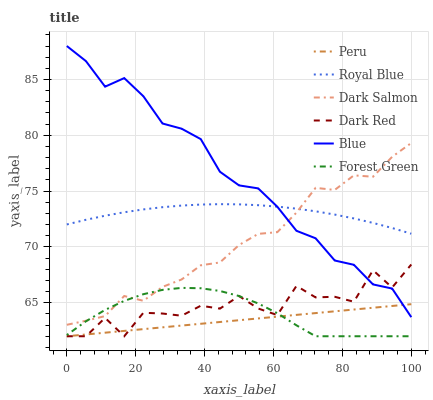Does Peru have the minimum area under the curve?
Answer yes or no. Yes. Does Blue have the maximum area under the curve?
Answer yes or no. Yes. Does Dark Red have the minimum area under the curve?
Answer yes or no. No. Does Dark Red have the maximum area under the curve?
Answer yes or no. No. Is Peru the smoothest?
Answer yes or no. Yes. Is Dark Red the roughest?
Answer yes or no. Yes. Is Dark Salmon the smoothest?
Answer yes or no. No. Is Dark Salmon the roughest?
Answer yes or no. No. Does Dark Salmon have the lowest value?
Answer yes or no. No. Does Blue have the highest value?
Answer yes or no. Yes. Does Dark Red have the highest value?
Answer yes or no. No. Is Dark Red less than Royal Blue?
Answer yes or no. Yes. Is Dark Salmon greater than Peru?
Answer yes or no. Yes. Does Blue intersect Dark Red?
Answer yes or no. Yes. Is Blue less than Dark Red?
Answer yes or no. No. Is Blue greater than Dark Red?
Answer yes or no. No. Does Dark Red intersect Royal Blue?
Answer yes or no. No. 